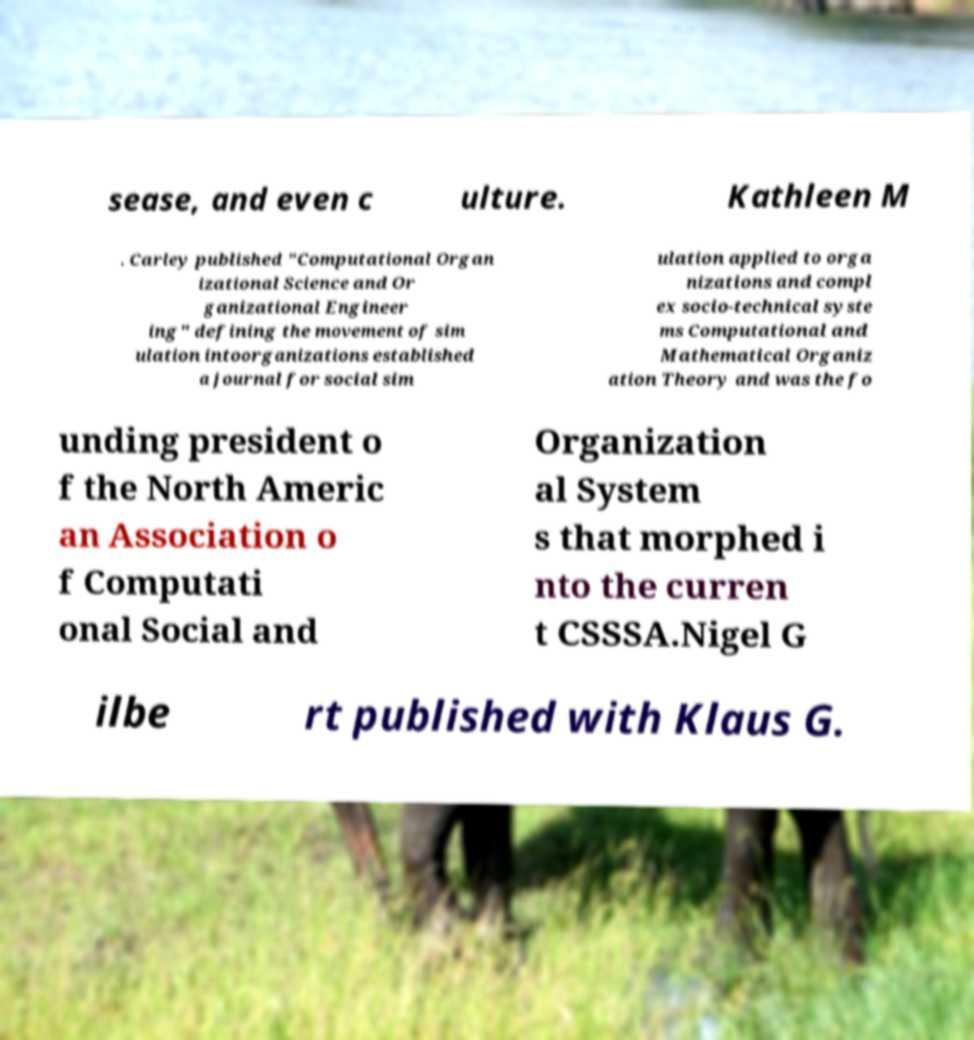I need the written content from this picture converted into text. Can you do that? sease, and even c ulture. Kathleen M . Carley published "Computational Organ izational Science and Or ganizational Engineer ing" defining the movement of sim ulation intoorganizations established a journal for social sim ulation applied to orga nizations and compl ex socio-technical syste ms Computational and Mathematical Organiz ation Theory and was the fo unding president o f the North Americ an Association o f Computati onal Social and Organization al System s that morphed i nto the curren t CSSSA.Nigel G ilbe rt published with Klaus G. 